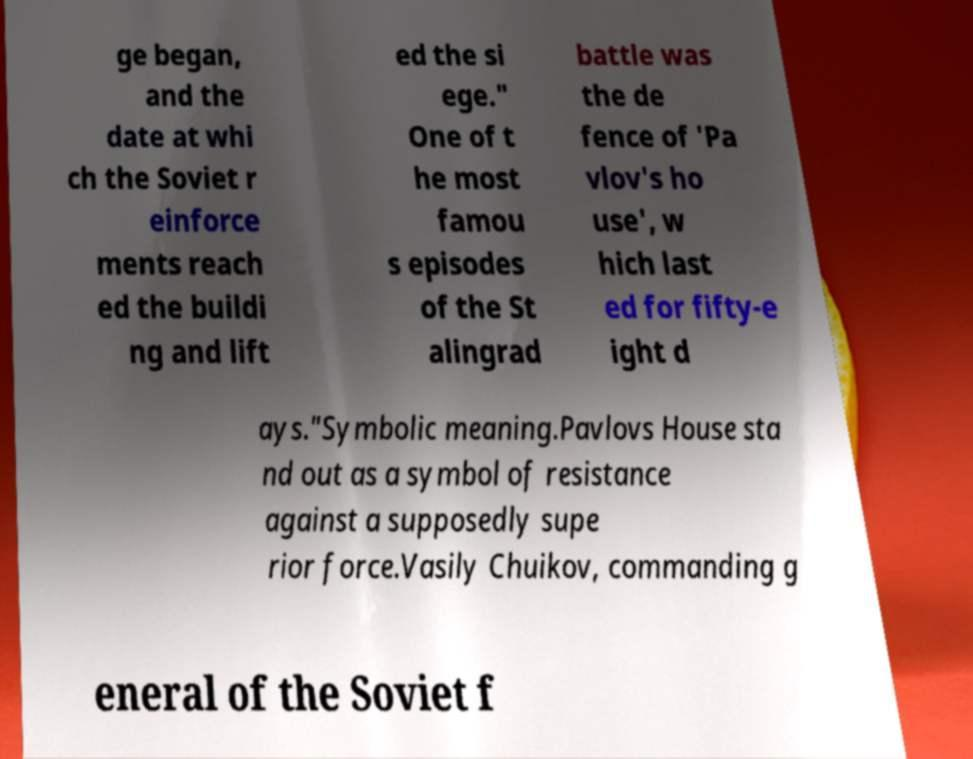Please read and relay the text visible in this image. What does it say? ge began, and the date at whi ch the Soviet r einforce ments reach ed the buildi ng and lift ed the si ege." One of t he most famou s episodes of the St alingrad battle was the de fence of 'Pa vlov's ho use', w hich last ed for fifty-e ight d ays."Symbolic meaning.Pavlovs House sta nd out as a symbol of resistance against a supposedly supe rior force.Vasily Chuikov, commanding g eneral of the Soviet f 